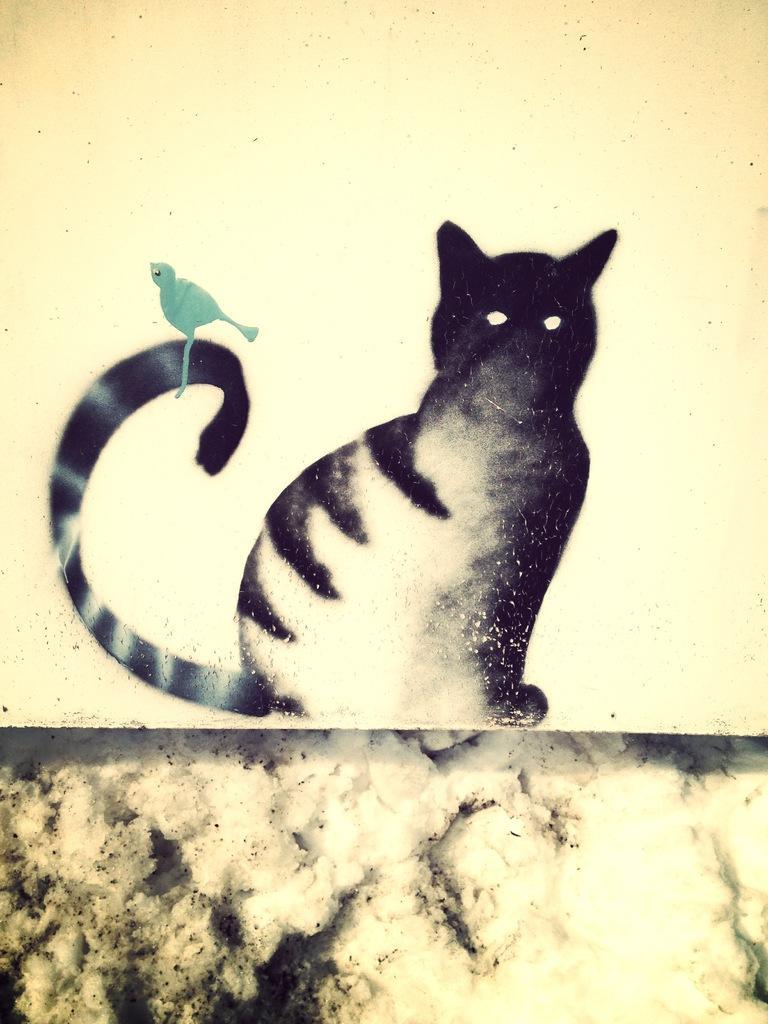Can you describe this image briefly? In this image there is a painting of a cat and a bird. 